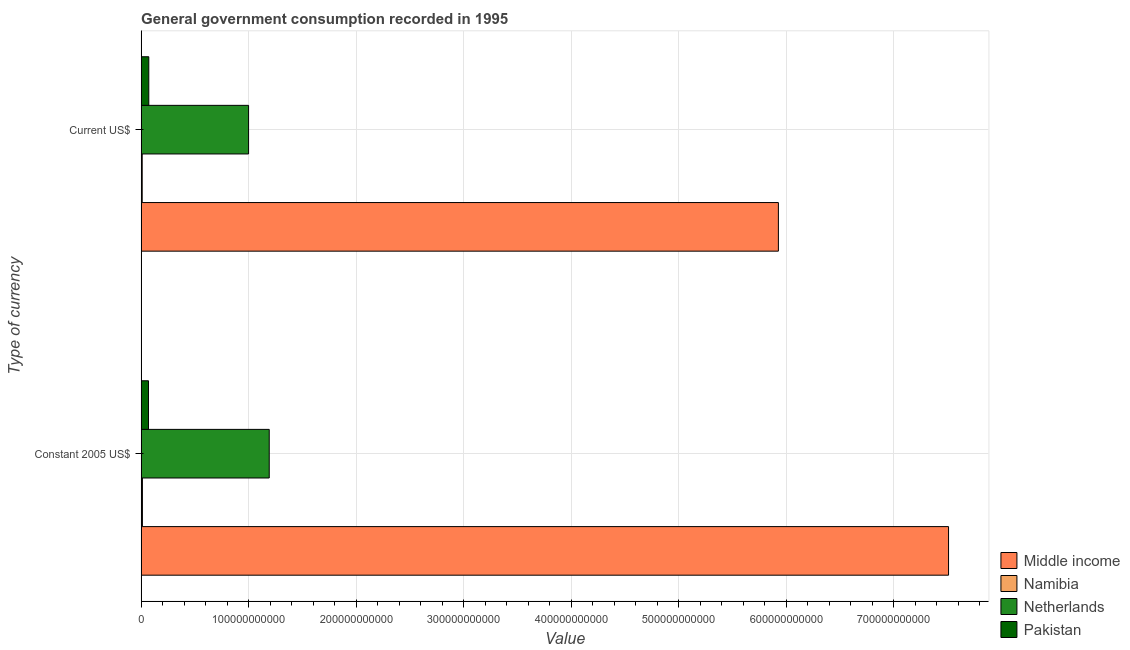How many groups of bars are there?
Provide a succinct answer. 2. Are the number of bars on each tick of the Y-axis equal?
Ensure brevity in your answer.  Yes. How many bars are there on the 1st tick from the bottom?
Your answer should be compact. 4. What is the label of the 2nd group of bars from the top?
Your response must be concise. Constant 2005 US$. What is the value consumed in constant 2005 us$ in Namibia?
Your answer should be very brief. 1.18e+09. Across all countries, what is the maximum value consumed in current us$?
Your answer should be very brief. 5.93e+11. Across all countries, what is the minimum value consumed in constant 2005 us$?
Your answer should be compact. 1.18e+09. In which country was the value consumed in constant 2005 us$ maximum?
Your answer should be compact. Middle income. In which country was the value consumed in constant 2005 us$ minimum?
Your answer should be compact. Namibia. What is the total value consumed in constant 2005 us$ in the graph?
Provide a short and direct response. 8.78e+11. What is the difference between the value consumed in current us$ in Namibia and that in Pakistan?
Your answer should be very brief. -6.13e+09. What is the difference between the value consumed in constant 2005 us$ in Namibia and the value consumed in current us$ in Pakistan?
Offer a very short reply. -5.94e+09. What is the average value consumed in constant 2005 us$ per country?
Your response must be concise. 2.19e+11. What is the difference between the value consumed in constant 2005 us$ and value consumed in current us$ in Middle income?
Give a very brief answer. 1.58e+11. What is the ratio of the value consumed in current us$ in Netherlands to that in Pakistan?
Ensure brevity in your answer.  14.03. What does the 1st bar from the top in Constant 2005 US$ represents?
Provide a short and direct response. Pakistan. What does the 3rd bar from the bottom in Constant 2005 US$ represents?
Offer a terse response. Netherlands. Are all the bars in the graph horizontal?
Your answer should be compact. Yes. What is the difference between two consecutive major ticks on the X-axis?
Your answer should be compact. 1.00e+11. Are the values on the major ticks of X-axis written in scientific E-notation?
Provide a succinct answer. No. Does the graph contain grids?
Provide a succinct answer. Yes. Where does the legend appear in the graph?
Your answer should be compact. Bottom right. What is the title of the graph?
Give a very brief answer. General government consumption recorded in 1995. Does "Cayman Islands" appear as one of the legend labels in the graph?
Offer a very short reply. No. What is the label or title of the X-axis?
Your answer should be very brief. Value. What is the label or title of the Y-axis?
Make the answer very short. Type of currency. What is the Value in Middle income in Constant 2005 US$?
Your answer should be compact. 7.51e+11. What is the Value of Namibia in Constant 2005 US$?
Your response must be concise. 1.18e+09. What is the Value of Netherlands in Constant 2005 US$?
Your answer should be very brief. 1.19e+11. What is the Value in Pakistan in Constant 2005 US$?
Provide a short and direct response. 6.84e+09. What is the Value of Middle income in Current US$?
Your answer should be very brief. 5.93e+11. What is the Value of Namibia in Current US$?
Offer a terse response. 9.88e+08. What is the Value in Netherlands in Current US$?
Keep it short and to the point. 9.99e+1. What is the Value of Pakistan in Current US$?
Give a very brief answer. 7.12e+09. Across all Type of currency, what is the maximum Value in Middle income?
Your answer should be compact. 7.51e+11. Across all Type of currency, what is the maximum Value of Namibia?
Offer a terse response. 1.18e+09. Across all Type of currency, what is the maximum Value of Netherlands?
Keep it short and to the point. 1.19e+11. Across all Type of currency, what is the maximum Value in Pakistan?
Your answer should be compact. 7.12e+09. Across all Type of currency, what is the minimum Value of Middle income?
Ensure brevity in your answer.  5.93e+11. Across all Type of currency, what is the minimum Value of Namibia?
Make the answer very short. 9.88e+08. Across all Type of currency, what is the minimum Value of Netherlands?
Make the answer very short. 9.99e+1. Across all Type of currency, what is the minimum Value in Pakistan?
Your response must be concise. 6.84e+09. What is the total Value in Middle income in the graph?
Your answer should be very brief. 1.34e+12. What is the total Value of Namibia in the graph?
Your answer should be compact. 2.17e+09. What is the total Value in Netherlands in the graph?
Offer a very short reply. 2.19e+11. What is the total Value in Pakistan in the graph?
Give a very brief answer. 1.40e+1. What is the difference between the Value of Middle income in Constant 2005 US$ and that in Current US$?
Give a very brief answer. 1.58e+11. What is the difference between the Value of Namibia in Constant 2005 US$ and that in Current US$?
Keep it short and to the point. 1.90e+08. What is the difference between the Value of Netherlands in Constant 2005 US$ and that in Current US$?
Provide a short and direct response. 1.92e+1. What is the difference between the Value in Pakistan in Constant 2005 US$ and that in Current US$?
Your response must be concise. -2.80e+08. What is the difference between the Value of Middle income in Constant 2005 US$ and the Value of Namibia in Current US$?
Give a very brief answer. 7.50e+11. What is the difference between the Value in Middle income in Constant 2005 US$ and the Value in Netherlands in Current US$?
Give a very brief answer. 6.51e+11. What is the difference between the Value in Middle income in Constant 2005 US$ and the Value in Pakistan in Current US$?
Your answer should be compact. 7.44e+11. What is the difference between the Value in Namibia in Constant 2005 US$ and the Value in Netherlands in Current US$?
Your answer should be very brief. -9.87e+1. What is the difference between the Value in Namibia in Constant 2005 US$ and the Value in Pakistan in Current US$?
Ensure brevity in your answer.  -5.94e+09. What is the difference between the Value in Netherlands in Constant 2005 US$ and the Value in Pakistan in Current US$?
Your answer should be very brief. 1.12e+11. What is the average Value in Middle income per Type of currency?
Offer a terse response. 6.72e+11. What is the average Value of Namibia per Type of currency?
Your answer should be compact. 1.08e+09. What is the average Value in Netherlands per Type of currency?
Keep it short and to the point. 1.10e+11. What is the average Value in Pakistan per Type of currency?
Offer a very short reply. 6.98e+09. What is the difference between the Value of Middle income and Value of Namibia in Constant 2005 US$?
Ensure brevity in your answer.  7.50e+11. What is the difference between the Value in Middle income and Value in Netherlands in Constant 2005 US$?
Keep it short and to the point. 6.32e+11. What is the difference between the Value in Middle income and Value in Pakistan in Constant 2005 US$?
Keep it short and to the point. 7.44e+11. What is the difference between the Value of Namibia and Value of Netherlands in Constant 2005 US$?
Make the answer very short. -1.18e+11. What is the difference between the Value in Namibia and Value in Pakistan in Constant 2005 US$?
Give a very brief answer. -5.66e+09. What is the difference between the Value of Netherlands and Value of Pakistan in Constant 2005 US$?
Your answer should be compact. 1.12e+11. What is the difference between the Value of Middle income and Value of Namibia in Current US$?
Offer a very short reply. 5.92e+11. What is the difference between the Value in Middle income and Value in Netherlands in Current US$?
Offer a very short reply. 4.93e+11. What is the difference between the Value of Middle income and Value of Pakistan in Current US$?
Your answer should be compact. 5.85e+11. What is the difference between the Value of Namibia and Value of Netherlands in Current US$?
Offer a very short reply. -9.89e+1. What is the difference between the Value in Namibia and Value in Pakistan in Current US$?
Ensure brevity in your answer.  -6.13e+09. What is the difference between the Value in Netherlands and Value in Pakistan in Current US$?
Provide a short and direct response. 9.28e+1. What is the ratio of the Value in Middle income in Constant 2005 US$ to that in Current US$?
Keep it short and to the point. 1.27. What is the ratio of the Value in Namibia in Constant 2005 US$ to that in Current US$?
Your answer should be compact. 1.19. What is the ratio of the Value of Netherlands in Constant 2005 US$ to that in Current US$?
Offer a terse response. 1.19. What is the ratio of the Value of Pakistan in Constant 2005 US$ to that in Current US$?
Provide a short and direct response. 0.96. What is the difference between the highest and the second highest Value of Middle income?
Ensure brevity in your answer.  1.58e+11. What is the difference between the highest and the second highest Value of Namibia?
Provide a succinct answer. 1.90e+08. What is the difference between the highest and the second highest Value in Netherlands?
Provide a succinct answer. 1.92e+1. What is the difference between the highest and the second highest Value in Pakistan?
Make the answer very short. 2.80e+08. What is the difference between the highest and the lowest Value in Middle income?
Your answer should be compact. 1.58e+11. What is the difference between the highest and the lowest Value in Namibia?
Provide a succinct answer. 1.90e+08. What is the difference between the highest and the lowest Value in Netherlands?
Ensure brevity in your answer.  1.92e+1. What is the difference between the highest and the lowest Value of Pakistan?
Provide a short and direct response. 2.80e+08. 